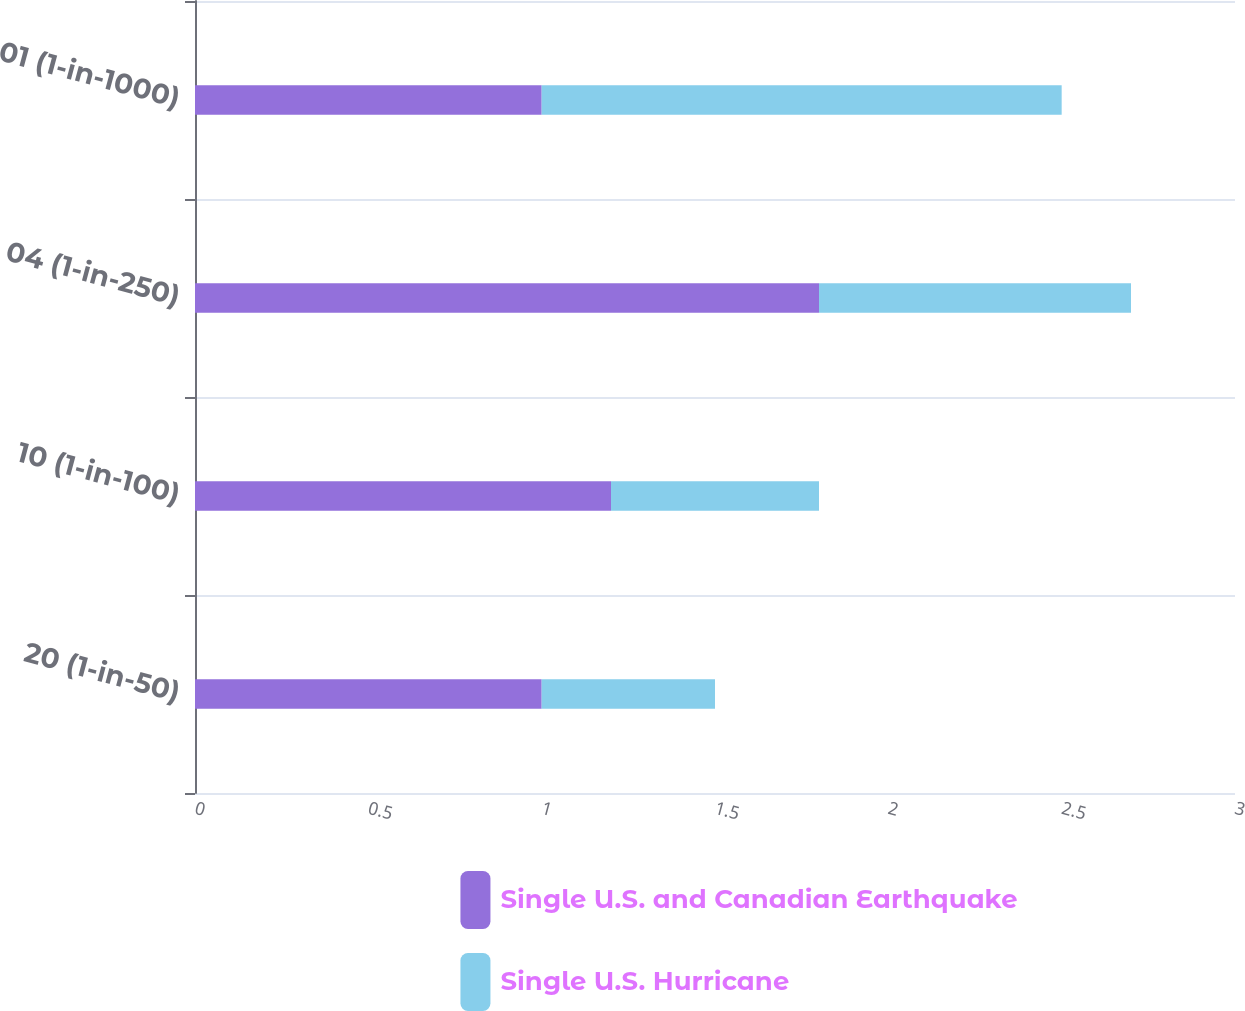<chart> <loc_0><loc_0><loc_500><loc_500><stacked_bar_chart><ecel><fcel>20 (1-in-50)<fcel>10 (1-in-100)<fcel>04 (1-in-250)<fcel>01 (1-in-1000)<nl><fcel>Single U.S. and Canadian Earthquake<fcel>1<fcel>1.2<fcel>1.8<fcel>1<nl><fcel>Single U.S. Hurricane<fcel>0.5<fcel>0.6<fcel>0.9<fcel>1.5<nl></chart> 